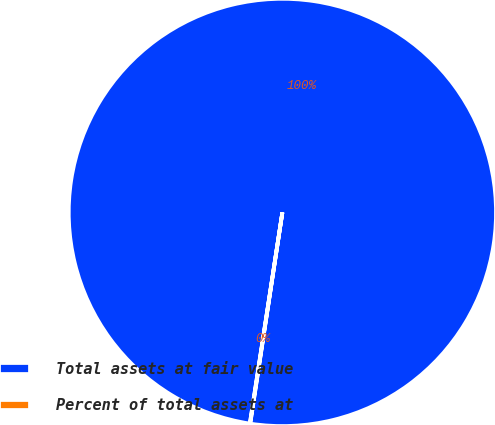<chart> <loc_0><loc_0><loc_500><loc_500><pie_chart><fcel>Total assets at fair value<fcel>Percent of total assets at<nl><fcel>99.97%<fcel>0.03%<nl></chart> 